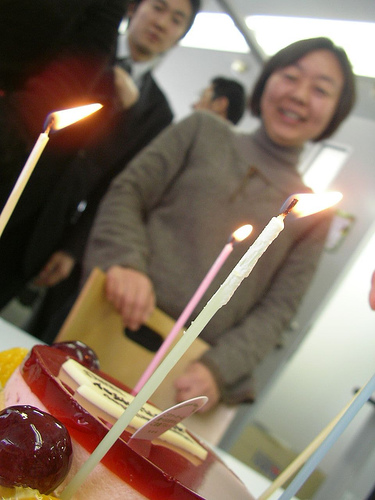How many people is there? There is one person visible in the foreground of the image, delightedly standing behind a cake with lit candles, suggesting a celebration such as a birthday or a similar event. 